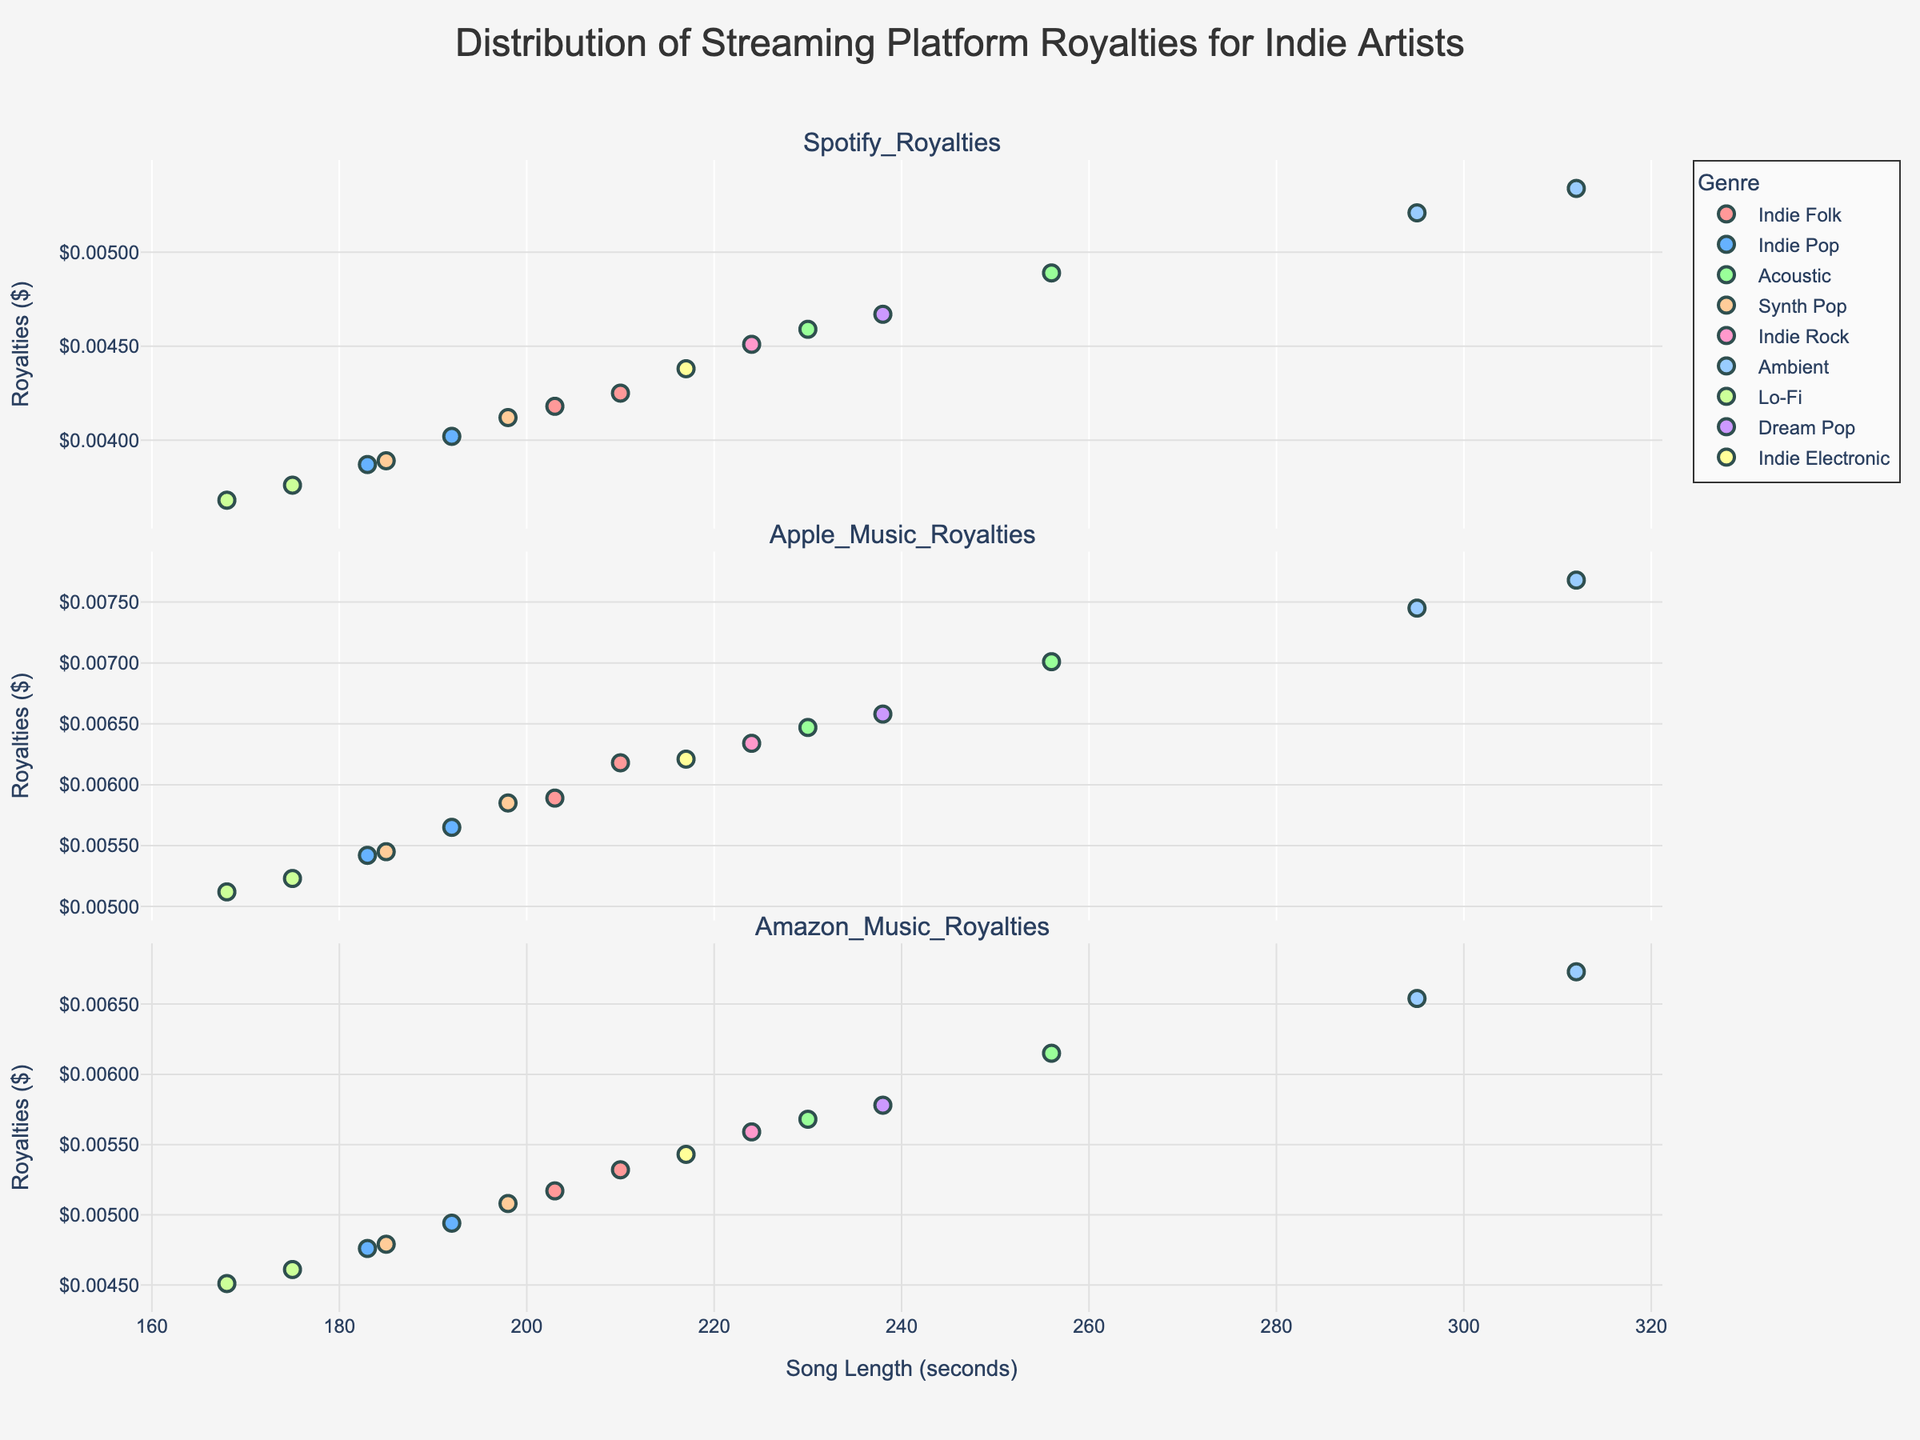What is the title of the figure? The title is often found at the top center of the figure. It provides a brief description of what the plot is about.
Answer: Distribution of Streaming Platform Royalties for Indie Artists How many genres are represented in the figure? The number of unique genres can be counted by looking at the legend, as each genre is represented by a different color and label.
Answer: 9 Which platform shows the highest royalties for Ambient music? Check the subplots labeled with streaming platform names and compare the y-values (royalties) corresponding to Ambient music data points.
Answer: Apple Music What is the range of song lengths (in seconds) for Indie Folk songs? Locate the Indie Folk songs in the plot by their color and check the x-axis values of the corresponding points to find the minimum and maximum lengths.
Answer: 203 - 210 seconds What is the average Spotify royalty for Indie Rock songs? Identify all the data points corresponding to Indie Rock in the Spotify subplot. Sum up their y-values (royalties) and divide by the number of points to get the average.
Answer: (0.00451) / 1 = 0.00451 Which genre seems to have the most consistent royalties across all platforms? Look for a genre whose data points (in all three subplots) form a close cluster with minimal vertical spread. This would indicate consistency in royalty values across platforms.
Answer: Lo-Fi Is there a noticeable trend between song length and royalties for Apple Music? Check the Apple Music subplot for any pattern (e.g., increasing, decreasing, or constant) in the data points along the x-axis (song length) and y-axis (royalties).
Answer: Longer songs tend to have higher royalties Are there more songs with royalties above $0.005 on Amazon Music than on Spotify? Count the data points in the Amazon Music subplot with y-values above 0.005 and compare with the corresponding count in the Spotify subplot.
Answer: Yes Which genre's songs have the highest variability in royalties on Spotify? Compare the spread of data points for each genre in the Spotify subplot. Higher variability is indicated by a wider vertical spread of points for the genre.
Answer: Acoustic Which platform has the lowest average royalties across all genres? Calculate the average royalty for each platform by summing all y-values in the respective subplot and dividing by the total number of points. Compare the averages to determine the lowest one.
Answer: Spotify 